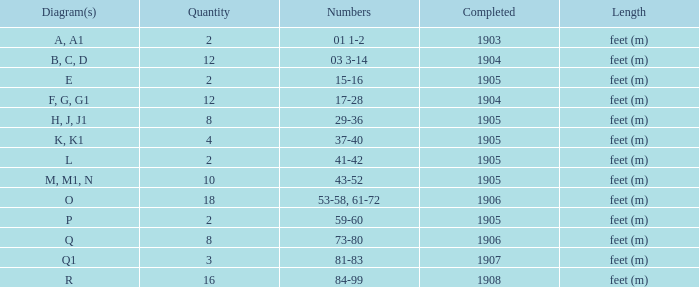What is the quantity of the item with the numbers of 29-36? 8.0. 